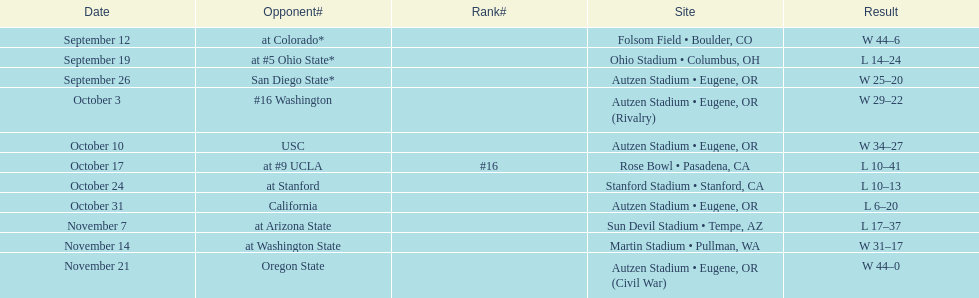Between september 26 and october 24, how many matches took place in eugene, or? 3. 